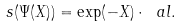<formula> <loc_0><loc_0><loc_500><loc_500>s ( \Psi ( X ) ) = \exp ( - X ) \cdot \ a l .</formula> 